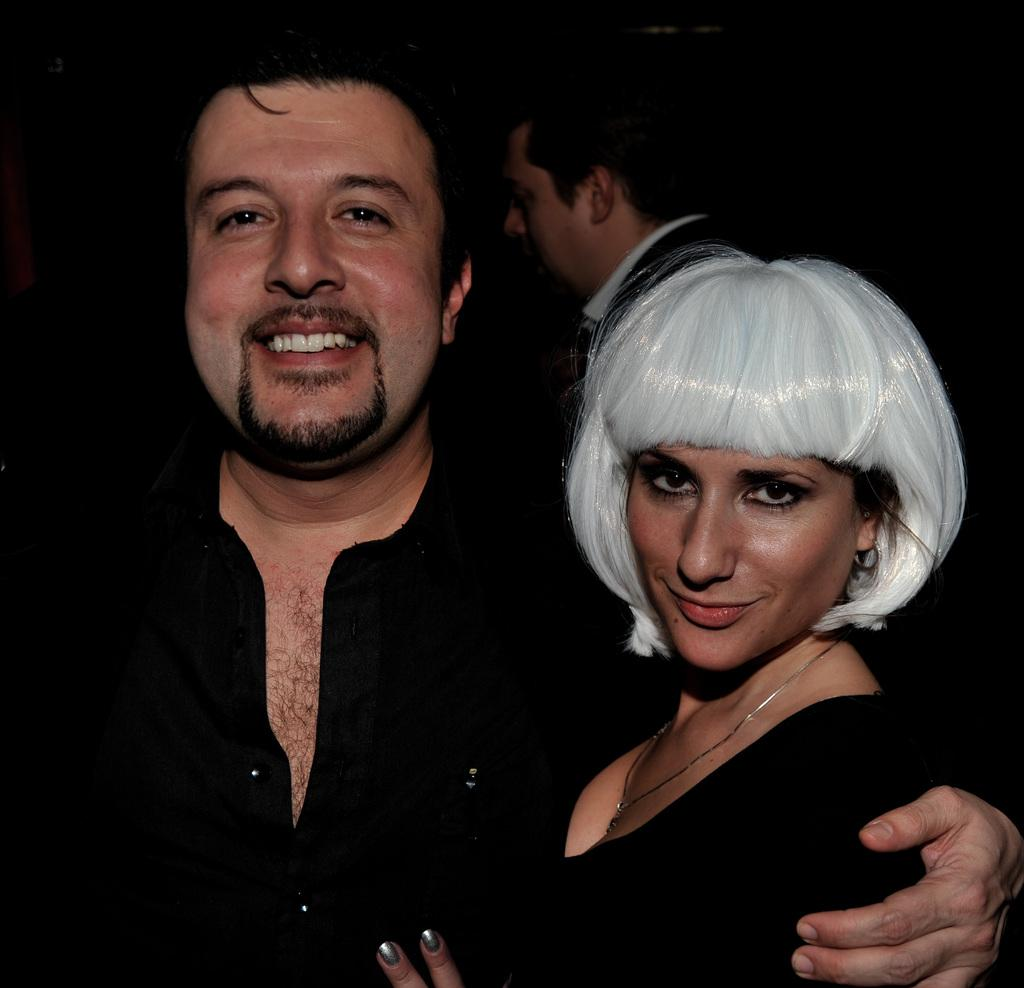What are the people in the image doing? The two persons in the image are standing and smiling. Can you describe the appearance of the woman in the image? The woman has white hair. Where is the third person located in the image? There is a person standing at the back of the image. What type of food is the woman regretting in the image? There is no food present in the image, and the woman is not shown regretting anything. 